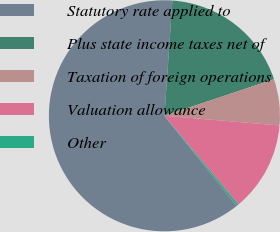Convert chart. <chart><loc_0><loc_0><loc_500><loc_500><pie_chart><fcel>Statutory rate applied to<fcel>Plus state income taxes net of<fcel>Taxation of foreign operations<fcel>Valuation allowance<fcel>Other<nl><fcel>61.84%<fcel>18.77%<fcel>6.46%<fcel>12.62%<fcel>0.31%<nl></chart> 